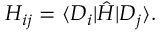Convert formula to latex. <formula><loc_0><loc_0><loc_500><loc_500>H _ { i j } = \langle D _ { i } | \hat { H } | D _ { j } \rangle .</formula> 